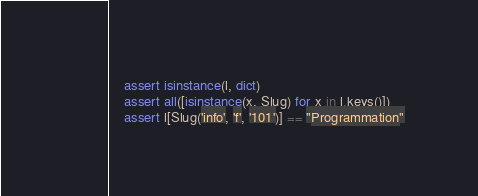<code> <loc_0><loc_0><loc_500><loc_500><_Python_>    assert isinstance(l, dict)
    assert all([isinstance(x, Slug) for x in l.keys()])
    assert l[Slug('info', 'f', '101')] == "Programmation"
</code> 